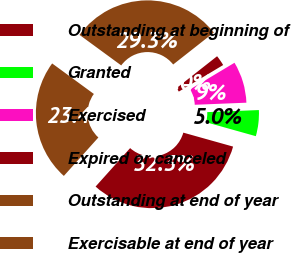Convert chart. <chart><loc_0><loc_0><loc_500><loc_500><pie_chart><fcel>Outstanding at beginning of<fcel>Granted<fcel>Exercised<fcel>Expired or canceled<fcel>Outstanding at end of year<fcel>Exercisable at end of year<nl><fcel>32.3%<fcel>4.99%<fcel>7.95%<fcel>2.02%<fcel>29.34%<fcel>23.41%<nl></chart> 